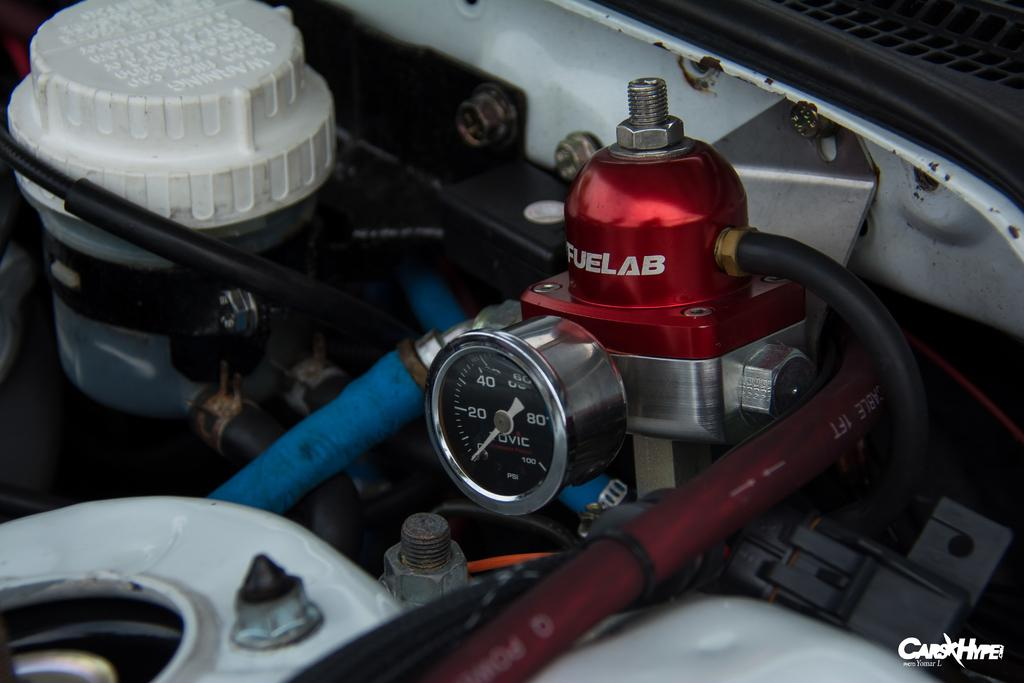What is the main subject of the image? The main subject of the image is an inside view of a car's bonnet. Can you describe the setting of the image? The image is set inside a car, specifically focusing on the bonnet area. What type of thread is being used to sew the wheel in the image? There is no wheel or thread present in the image; it is an inside view of a car's bonnet. Can you tell me how the mother is interacting with the car's bonnet in the image? There is no person, including a mother, present in the image; it is an inside view of a car's bonnet. 